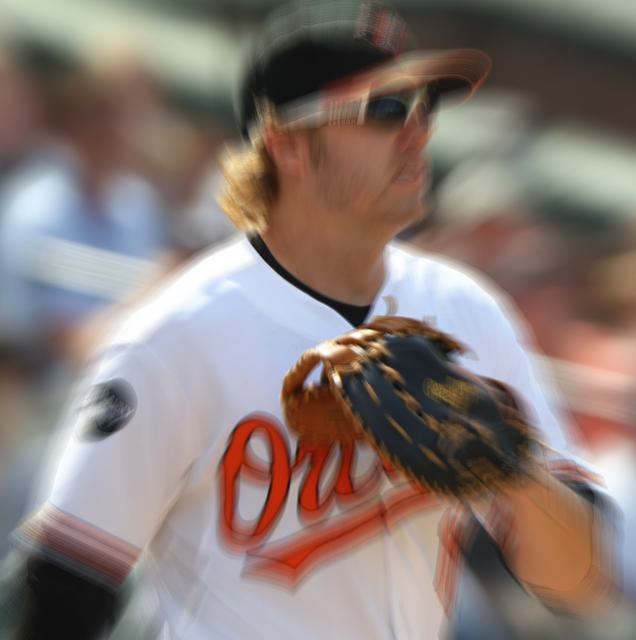Can you infer the time of day or the weather conditions during this game? Due to the brightness and the shadows cast on the player's uniform, it appears to be a sunny day. The time of day could likely be midday or early afternoon, given the intensity of the light. There are no visible signs of rain or overcast weather, suggesting the game is being played under fair weather conditions. 